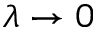Convert formula to latex. <formula><loc_0><loc_0><loc_500><loc_500>\lambda \to 0</formula> 